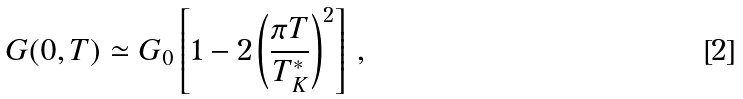<formula> <loc_0><loc_0><loc_500><loc_500>G ( 0 , T ) \simeq G _ { 0 } \left [ 1 - 2 \left ( \frac { \pi T } { T ^ { \ast } _ { K } } \right ) ^ { 2 } \right ] \, ,</formula> 